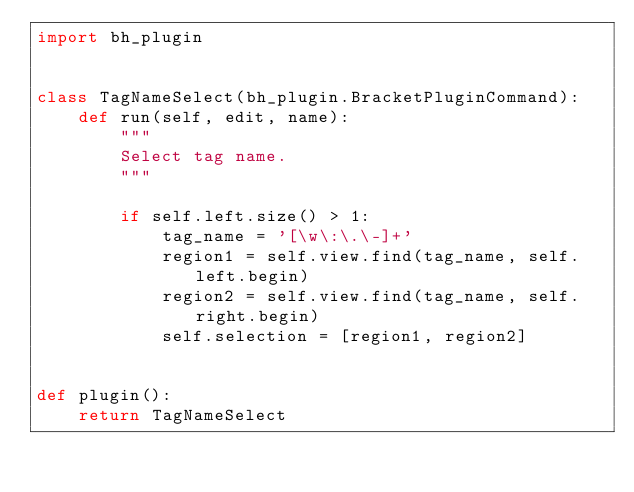<code> <loc_0><loc_0><loc_500><loc_500><_Python_>import bh_plugin


class TagNameSelect(bh_plugin.BracketPluginCommand):
    def run(self, edit, name):
        """
        Select tag name.
        """

        if self.left.size() > 1:
            tag_name = '[\w\:\.\-]+'
            region1 = self.view.find(tag_name, self.left.begin)
            region2 = self.view.find(tag_name, self.right.begin)
            self.selection = [region1, region2]


def plugin():
    return TagNameSelect
</code> 